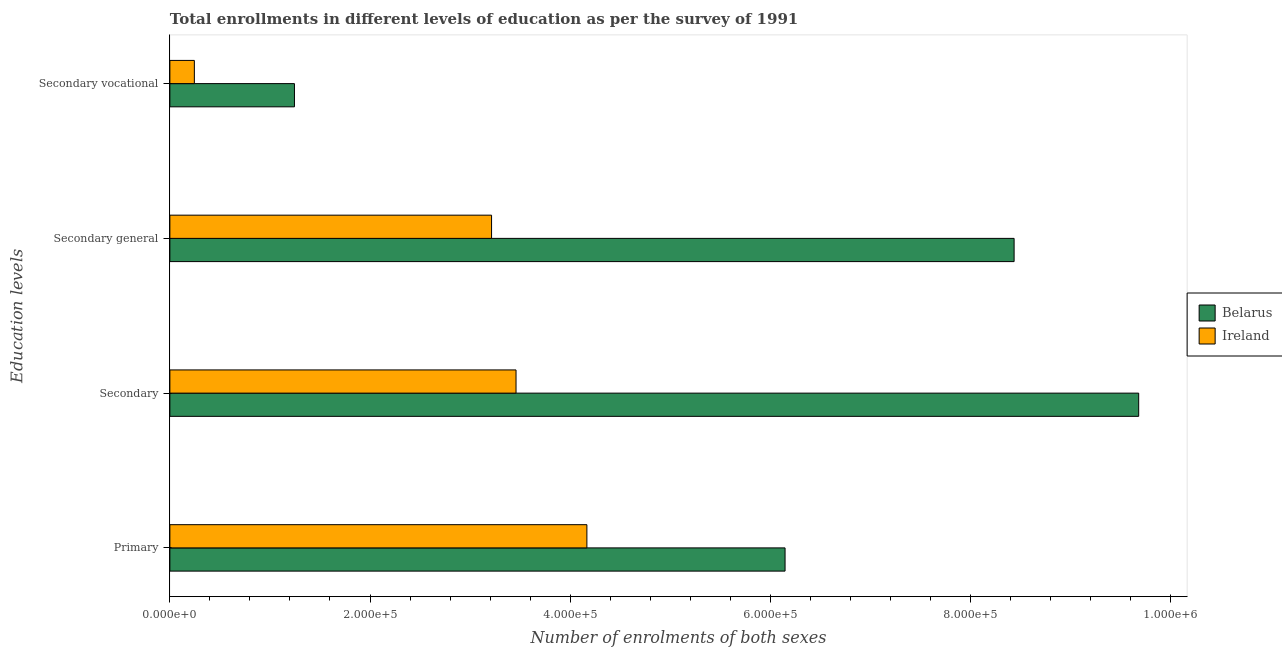How many groups of bars are there?
Provide a succinct answer. 4. Are the number of bars on each tick of the Y-axis equal?
Provide a short and direct response. Yes. How many bars are there on the 3rd tick from the top?
Provide a succinct answer. 2. How many bars are there on the 4th tick from the bottom?
Make the answer very short. 2. What is the label of the 2nd group of bars from the top?
Give a very brief answer. Secondary general. What is the number of enrolments in primary education in Belarus?
Keep it short and to the point. 6.15e+05. Across all countries, what is the maximum number of enrolments in secondary general education?
Make the answer very short. 8.44e+05. Across all countries, what is the minimum number of enrolments in secondary vocational education?
Keep it short and to the point. 2.45e+04. In which country was the number of enrolments in secondary education maximum?
Ensure brevity in your answer.  Belarus. In which country was the number of enrolments in secondary education minimum?
Provide a succinct answer. Ireland. What is the total number of enrolments in secondary vocational education in the graph?
Offer a terse response. 1.49e+05. What is the difference between the number of enrolments in secondary vocational education in Belarus and that in Ireland?
Provide a succinct answer. 1.00e+05. What is the difference between the number of enrolments in secondary education in Belarus and the number of enrolments in secondary general education in Ireland?
Provide a succinct answer. 6.47e+05. What is the average number of enrolments in secondary education per country?
Your response must be concise. 6.57e+05. What is the difference between the number of enrolments in secondary general education and number of enrolments in secondary education in Ireland?
Your answer should be very brief. -2.45e+04. What is the ratio of the number of enrolments in primary education in Belarus to that in Ireland?
Offer a very short reply. 1.48. Is the number of enrolments in primary education in Belarus less than that in Ireland?
Your answer should be very brief. No. Is the difference between the number of enrolments in primary education in Belarus and Ireland greater than the difference between the number of enrolments in secondary general education in Belarus and Ireland?
Make the answer very short. No. What is the difference between the highest and the second highest number of enrolments in primary education?
Keep it short and to the point. 1.98e+05. What is the difference between the highest and the lowest number of enrolments in secondary education?
Provide a succinct answer. 6.22e+05. In how many countries, is the number of enrolments in secondary vocational education greater than the average number of enrolments in secondary vocational education taken over all countries?
Your answer should be very brief. 1. Is it the case that in every country, the sum of the number of enrolments in primary education and number of enrolments in secondary general education is greater than the sum of number of enrolments in secondary education and number of enrolments in secondary vocational education?
Your answer should be very brief. No. What does the 1st bar from the top in Secondary represents?
Provide a succinct answer. Ireland. What does the 2nd bar from the bottom in Secondary general represents?
Offer a very short reply. Ireland. Is it the case that in every country, the sum of the number of enrolments in primary education and number of enrolments in secondary education is greater than the number of enrolments in secondary general education?
Your response must be concise. Yes. How many bars are there?
Keep it short and to the point. 8. What is the difference between two consecutive major ticks on the X-axis?
Keep it short and to the point. 2.00e+05. Are the values on the major ticks of X-axis written in scientific E-notation?
Ensure brevity in your answer.  Yes. Does the graph contain any zero values?
Your answer should be very brief. No. Does the graph contain grids?
Provide a short and direct response. No. Where does the legend appear in the graph?
Provide a short and direct response. Center right. How are the legend labels stacked?
Keep it short and to the point. Vertical. What is the title of the graph?
Ensure brevity in your answer.  Total enrollments in different levels of education as per the survey of 1991. Does "Chad" appear as one of the legend labels in the graph?
Your answer should be very brief. No. What is the label or title of the X-axis?
Offer a very short reply. Number of enrolments of both sexes. What is the label or title of the Y-axis?
Ensure brevity in your answer.  Education levels. What is the Number of enrolments of both sexes in Belarus in Primary?
Make the answer very short. 6.15e+05. What is the Number of enrolments of both sexes of Ireland in Primary?
Your answer should be very brief. 4.17e+05. What is the Number of enrolments of both sexes in Belarus in Secondary?
Your answer should be compact. 9.68e+05. What is the Number of enrolments of both sexes of Ireland in Secondary?
Keep it short and to the point. 3.46e+05. What is the Number of enrolments of both sexes of Belarus in Secondary general?
Provide a short and direct response. 8.44e+05. What is the Number of enrolments of both sexes in Ireland in Secondary general?
Offer a very short reply. 3.21e+05. What is the Number of enrolments of both sexes in Belarus in Secondary vocational?
Keep it short and to the point. 1.24e+05. What is the Number of enrolments of both sexes of Ireland in Secondary vocational?
Keep it short and to the point. 2.45e+04. Across all Education levels, what is the maximum Number of enrolments of both sexes in Belarus?
Offer a terse response. 9.68e+05. Across all Education levels, what is the maximum Number of enrolments of both sexes in Ireland?
Offer a very short reply. 4.17e+05. Across all Education levels, what is the minimum Number of enrolments of both sexes in Belarus?
Your answer should be very brief. 1.24e+05. Across all Education levels, what is the minimum Number of enrolments of both sexes in Ireland?
Your answer should be very brief. 2.45e+04. What is the total Number of enrolments of both sexes in Belarus in the graph?
Your response must be concise. 2.55e+06. What is the total Number of enrolments of both sexes of Ireland in the graph?
Keep it short and to the point. 1.11e+06. What is the difference between the Number of enrolments of both sexes in Belarus in Primary and that in Secondary?
Your answer should be compact. -3.53e+05. What is the difference between the Number of enrolments of both sexes in Ireland in Primary and that in Secondary?
Ensure brevity in your answer.  7.08e+04. What is the difference between the Number of enrolments of both sexes of Belarus in Primary and that in Secondary general?
Ensure brevity in your answer.  -2.29e+05. What is the difference between the Number of enrolments of both sexes of Ireland in Primary and that in Secondary general?
Offer a terse response. 9.53e+04. What is the difference between the Number of enrolments of both sexes of Belarus in Primary and that in Secondary vocational?
Ensure brevity in your answer.  4.90e+05. What is the difference between the Number of enrolments of both sexes in Ireland in Primary and that in Secondary vocational?
Offer a very short reply. 3.92e+05. What is the difference between the Number of enrolments of both sexes of Belarus in Secondary and that in Secondary general?
Your response must be concise. 1.24e+05. What is the difference between the Number of enrolments of both sexes of Ireland in Secondary and that in Secondary general?
Your response must be concise. 2.45e+04. What is the difference between the Number of enrolments of both sexes of Belarus in Secondary and that in Secondary vocational?
Keep it short and to the point. 8.44e+05. What is the difference between the Number of enrolments of both sexes of Ireland in Secondary and that in Secondary vocational?
Provide a short and direct response. 3.21e+05. What is the difference between the Number of enrolments of both sexes in Belarus in Secondary general and that in Secondary vocational?
Your answer should be compact. 7.19e+05. What is the difference between the Number of enrolments of both sexes of Ireland in Secondary general and that in Secondary vocational?
Offer a terse response. 2.97e+05. What is the difference between the Number of enrolments of both sexes in Belarus in Primary and the Number of enrolments of both sexes in Ireland in Secondary?
Provide a short and direct response. 2.69e+05. What is the difference between the Number of enrolments of both sexes of Belarus in Primary and the Number of enrolments of both sexes of Ireland in Secondary general?
Provide a succinct answer. 2.93e+05. What is the difference between the Number of enrolments of both sexes of Belarus in Primary and the Number of enrolments of both sexes of Ireland in Secondary vocational?
Make the answer very short. 5.90e+05. What is the difference between the Number of enrolments of both sexes in Belarus in Secondary and the Number of enrolments of both sexes in Ireland in Secondary general?
Offer a very short reply. 6.47e+05. What is the difference between the Number of enrolments of both sexes of Belarus in Secondary and the Number of enrolments of both sexes of Ireland in Secondary vocational?
Give a very brief answer. 9.44e+05. What is the difference between the Number of enrolments of both sexes of Belarus in Secondary general and the Number of enrolments of both sexes of Ireland in Secondary vocational?
Ensure brevity in your answer.  8.19e+05. What is the average Number of enrolments of both sexes in Belarus per Education levels?
Your response must be concise. 6.38e+05. What is the average Number of enrolments of both sexes of Ireland per Education levels?
Your answer should be compact. 2.77e+05. What is the difference between the Number of enrolments of both sexes of Belarus and Number of enrolments of both sexes of Ireland in Primary?
Offer a terse response. 1.98e+05. What is the difference between the Number of enrolments of both sexes in Belarus and Number of enrolments of both sexes in Ireland in Secondary?
Provide a short and direct response. 6.22e+05. What is the difference between the Number of enrolments of both sexes of Belarus and Number of enrolments of both sexes of Ireland in Secondary general?
Keep it short and to the point. 5.22e+05. What is the difference between the Number of enrolments of both sexes in Belarus and Number of enrolments of both sexes in Ireland in Secondary vocational?
Offer a terse response. 1.00e+05. What is the ratio of the Number of enrolments of both sexes in Belarus in Primary to that in Secondary?
Provide a short and direct response. 0.64. What is the ratio of the Number of enrolments of both sexes of Ireland in Primary to that in Secondary?
Provide a short and direct response. 1.2. What is the ratio of the Number of enrolments of both sexes in Belarus in Primary to that in Secondary general?
Provide a succinct answer. 0.73. What is the ratio of the Number of enrolments of both sexes in Ireland in Primary to that in Secondary general?
Your answer should be very brief. 1.3. What is the ratio of the Number of enrolments of both sexes of Belarus in Primary to that in Secondary vocational?
Make the answer very short. 4.94. What is the ratio of the Number of enrolments of both sexes in Ireland in Primary to that in Secondary vocational?
Ensure brevity in your answer.  17.04. What is the ratio of the Number of enrolments of both sexes of Belarus in Secondary to that in Secondary general?
Provide a succinct answer. 1.15. What is the ratio of the Number of enrolments of both sexes of Ireland in Secondary to that in Secondary general?
Your answer should be compact. 1.08. What is the ratio of the Number of enrolments of both sexes of Belarus in Secondary to that in Secondary vocational?
Ensure brevity in your answer.  7.78. What is the ratio of the Number of enrolments of both sexes of Ireland in Secondary to that in Secondary vocational?
Provide a succinct answer. 14.14. What is the ratio of the Number of enrolments of both sexes in Belarus in Secondary general to that in Secondary vocational?
Keep it short and to the point. 6.78. What is the ratio of the Number of enrolments of both sexes in Ireland in Secondary general to that in Secondary vocational?
Offer a very short reply. 13.14. What is the difference between the highest and the second highest Number of enrolments of both sexes in Belarus?
Provide a short and direct response. 1.24e+05. What is the difference between the highest and the second highest Number of enrolments of both sexes of Ireland?
Give a very brief answer. 7.08e+04. What is the difference between the highest and the lowest Number of enrolments of both sexes in Belarus?
Offer a very short reply. 8.44e+05. What is the difference between the highest and the lowest Number of enrolments of both sexes of Ireland?
Provide a short and direct response. 3.92e+05. 